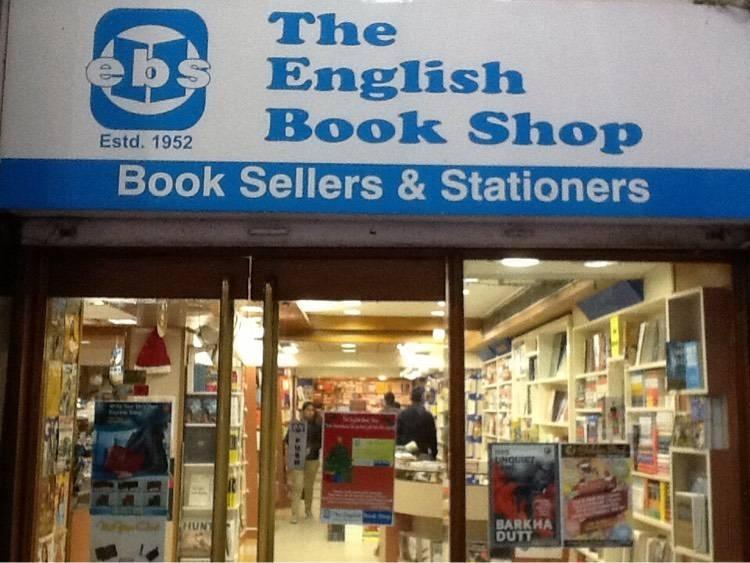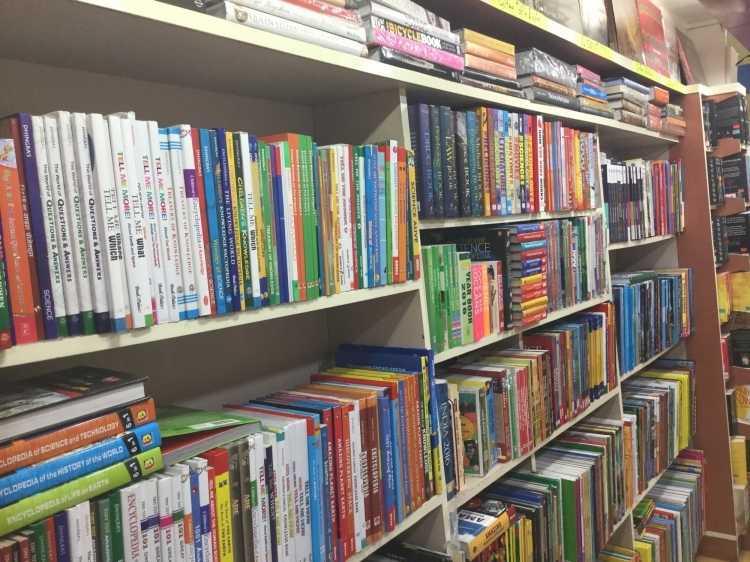The first image is the image on the left, the second image is the image on the right. For the images shown, is this caption "One image is taken from outside the shop." true? Answer yes or no. Yes. The first image is the image on the left, the second image is the image on the right. Examine the images to the left and right. Is the description "The exterior of a bookshop with plate glass windows is seen in one image, while a second image shows interior racks of books." accurate? Answer yes or no. Yes. 